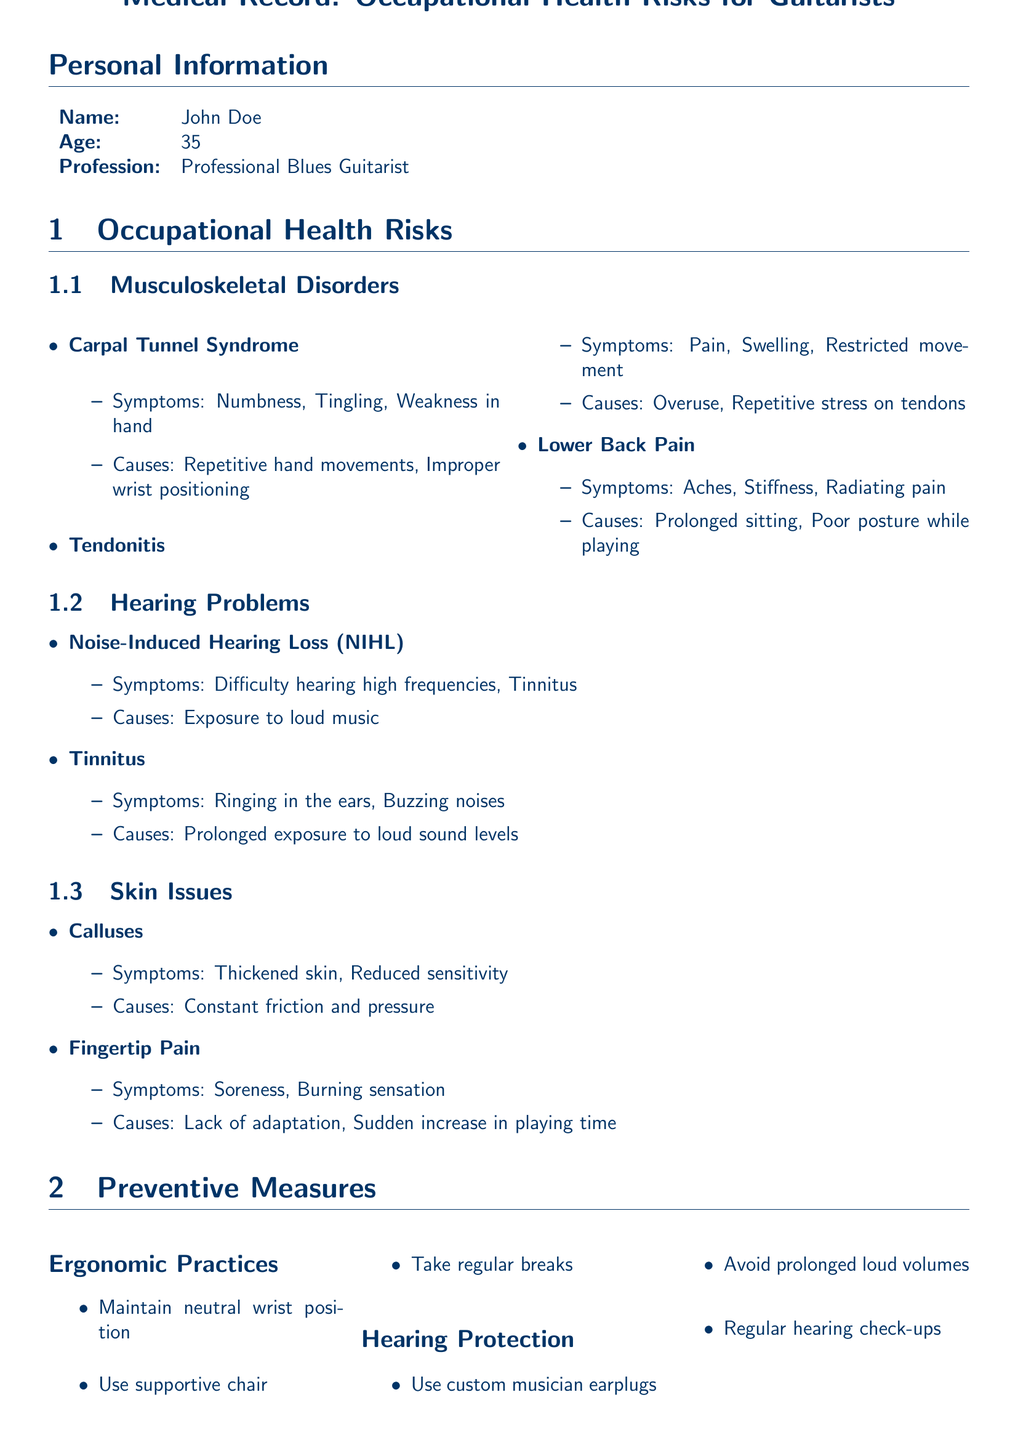What is the age of the patient? The document states the patient's age in the Personal Information section.
Answer: 35 What are two symptoms of Carpal Tunnel Syndrome? The symptoms are listed under Musculoskeletal Disorders in the document.
Answer: Numbness, Tingling What causes Noise-Induced Hearing Loss (NIHL)? The document specifies causes in the Hearing Problems section.
Answer: Exposure to loud music What preventive measure is recommended for maintaining hand health? The document lists preventive measures under the Hand Health subheading.
Answer: Gradually increase playing time How many subsections are included in the Occupational Health Risks section? The number of subsections can be counted from the Occupational Health Risks section.
Answer: Three What is one of the reasons for lower back pain according to the document? The document mentions causes of lower back pain in the Musculoskeletal Disorders section.
Answer: Poor posture while playing What type of document is this? Understanding the overall purpose of the information provided in the document.
Answer: Medical Record What is the patient's profession? The document clearly states the patient's profession in the Personal Information section.
Answer: Professional Blues Guitarist 